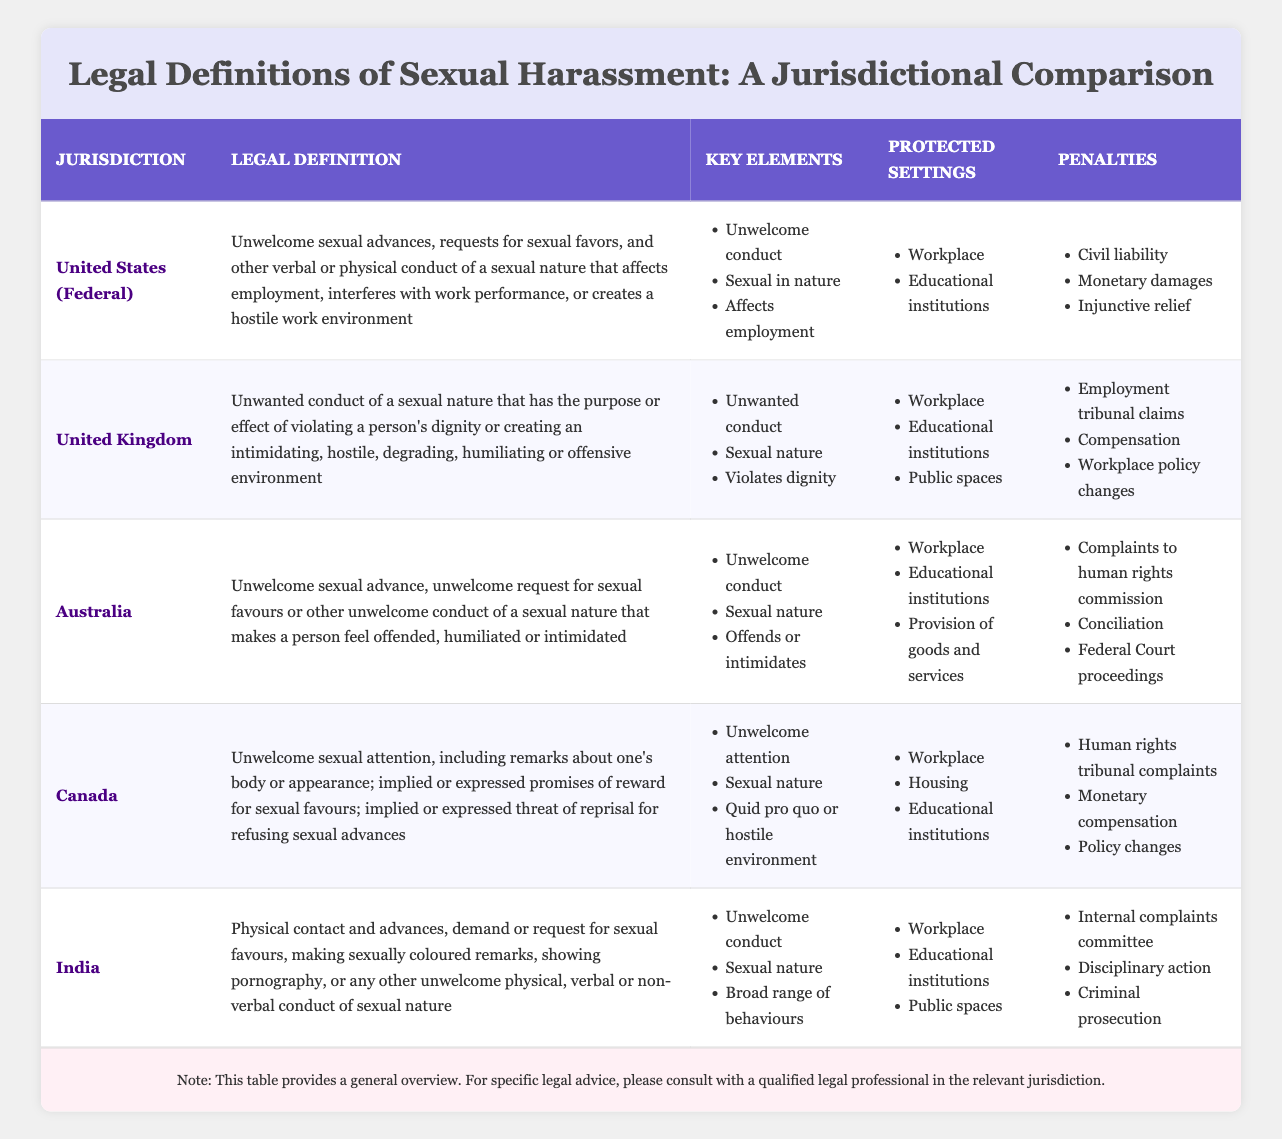What is the legal definition of sexual harassment in the United Kingdom? The table lists the UK legal definition as "Unwanted conduct of a sexual nature that has the purpose or effect of violating a person's dignity or creating an intimidating, hostile, degrading, humiliating or offensive environment."
Answer: Unwanted conduct of a sexual nature that has the purpose or effect of violating a person's dignity or creating an intimidating, hostile, degrading, humiliating or offensive environment How many jurisdictions provide protection in public spaces against sexual harassment? The jurisdictions that provide protection in public spaces are the United Kingdom, Australia, and India. Therefore, there are three jurisdictions.
Answer: 3 Is sexual harassment defined the same way in all listed jurisdictions? The definitions differ among jurisdictions as they emphasize different aspects, such as "unwelcome conduct" in the US and "violating dignity" in the UK.
Answer: No What penalties are applicable in Canada for sexual harassment? The table shows that Canada imposes penalties such as "Human rights tribunal complaints," "Monetary compensation," and "Policy changes."
Answer: Human rights tribunal complaints, monetary compensation, policy changes Which jurisdiction has the broadest range of behaviors included in its legal definition of sexual harassment? India’s legal definition includes various forms of conduct, stating "a broad range of behaviours," making it the most inclusive among the listed jurisdictions.
Answer: India How many total key elements are listed for sexual harassment in Australia, Canada, and the United Kingdom? Australia has 3 key elements, Canada has 3, and the United Kingdom has 3. Adding them gives 3 + 3 + 3 = 9 total key elements.
Answer: 9 Does the United States (Federal) include educational institutions in the protected settings for sexual harassment? Yes, the protected settings for the United States (Federal) include "Workplace" and "Educational institutions."
Answer: Yes Which jurisdiction has the penalty of "Internal complaints committee"? The penalty of "Internal complaints committee" is listed under India, indicating its specific mechanism for addressing complaints.
Answer: India In which jurisdictions is "Educational institutions" listed as a protected setting? The jurisdictions that list "Educational institutions" as a protected setting are the United States (Federal), United Kingdom, Canada, Australia, and India.
Answer: United States (Federal), United Kingdom, Canada, Australia, India What is the relationship between 'unwelcome conduct' and the legal definition of sexual harassment across these jurisdictions? 'Unwelcome conduct' is a common key element found in the legal definitions of sexual harassment in the United States, Australia, and India, indicating that the perceived nature of conduct is substantial across these jurisdictions.
Answer: Common key element in multiple jurisdictions 